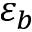Convert formula to latex. <formula><loc_0><loc_0><loc_500><loc_500>\varepsilon _ { b }</formula> 